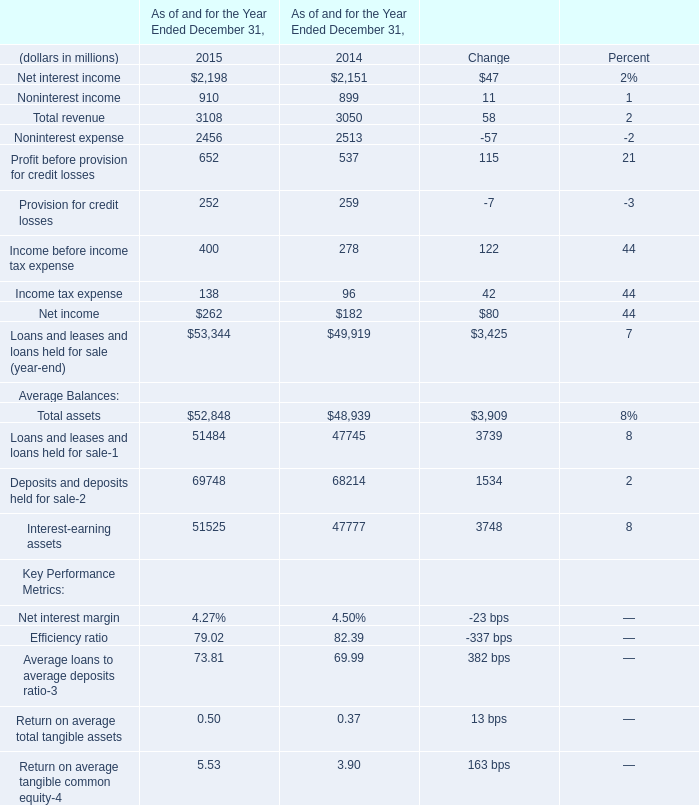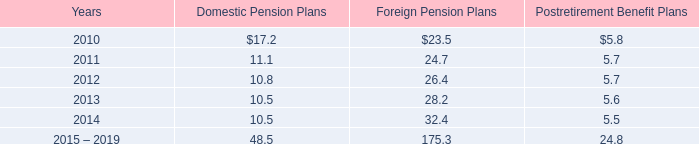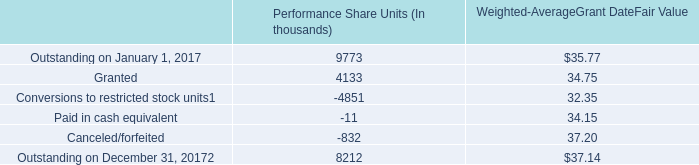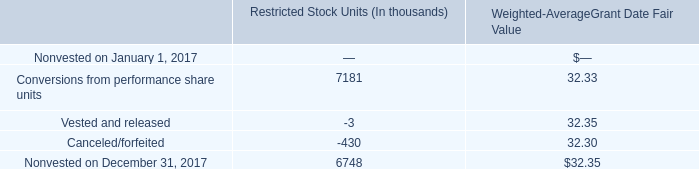what percentage of amounts expensed in 2009 came from discretionary company contributions? 
Computations: ((3.8 / 35.1) * 100)
Answer: 10.82621. 